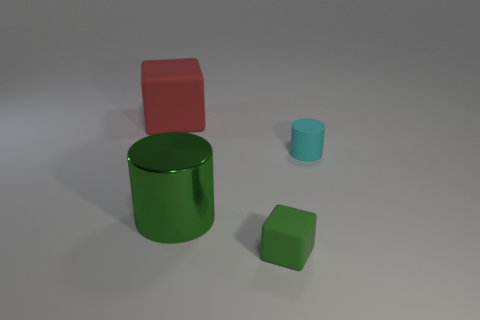Add 2 large shiny things. How many objects exist? 6 Subtract 1 green cylinders. How many objects are left? 3 Subtract all tiny cyan cylinders. Subtract all small rubber objects. How many objects are left? 1 Add 3 small cyan matte cylinders. How many small cyan matte cylinders are left? 4 Add 1 small cyan things. How many small cyan things exist? 2 